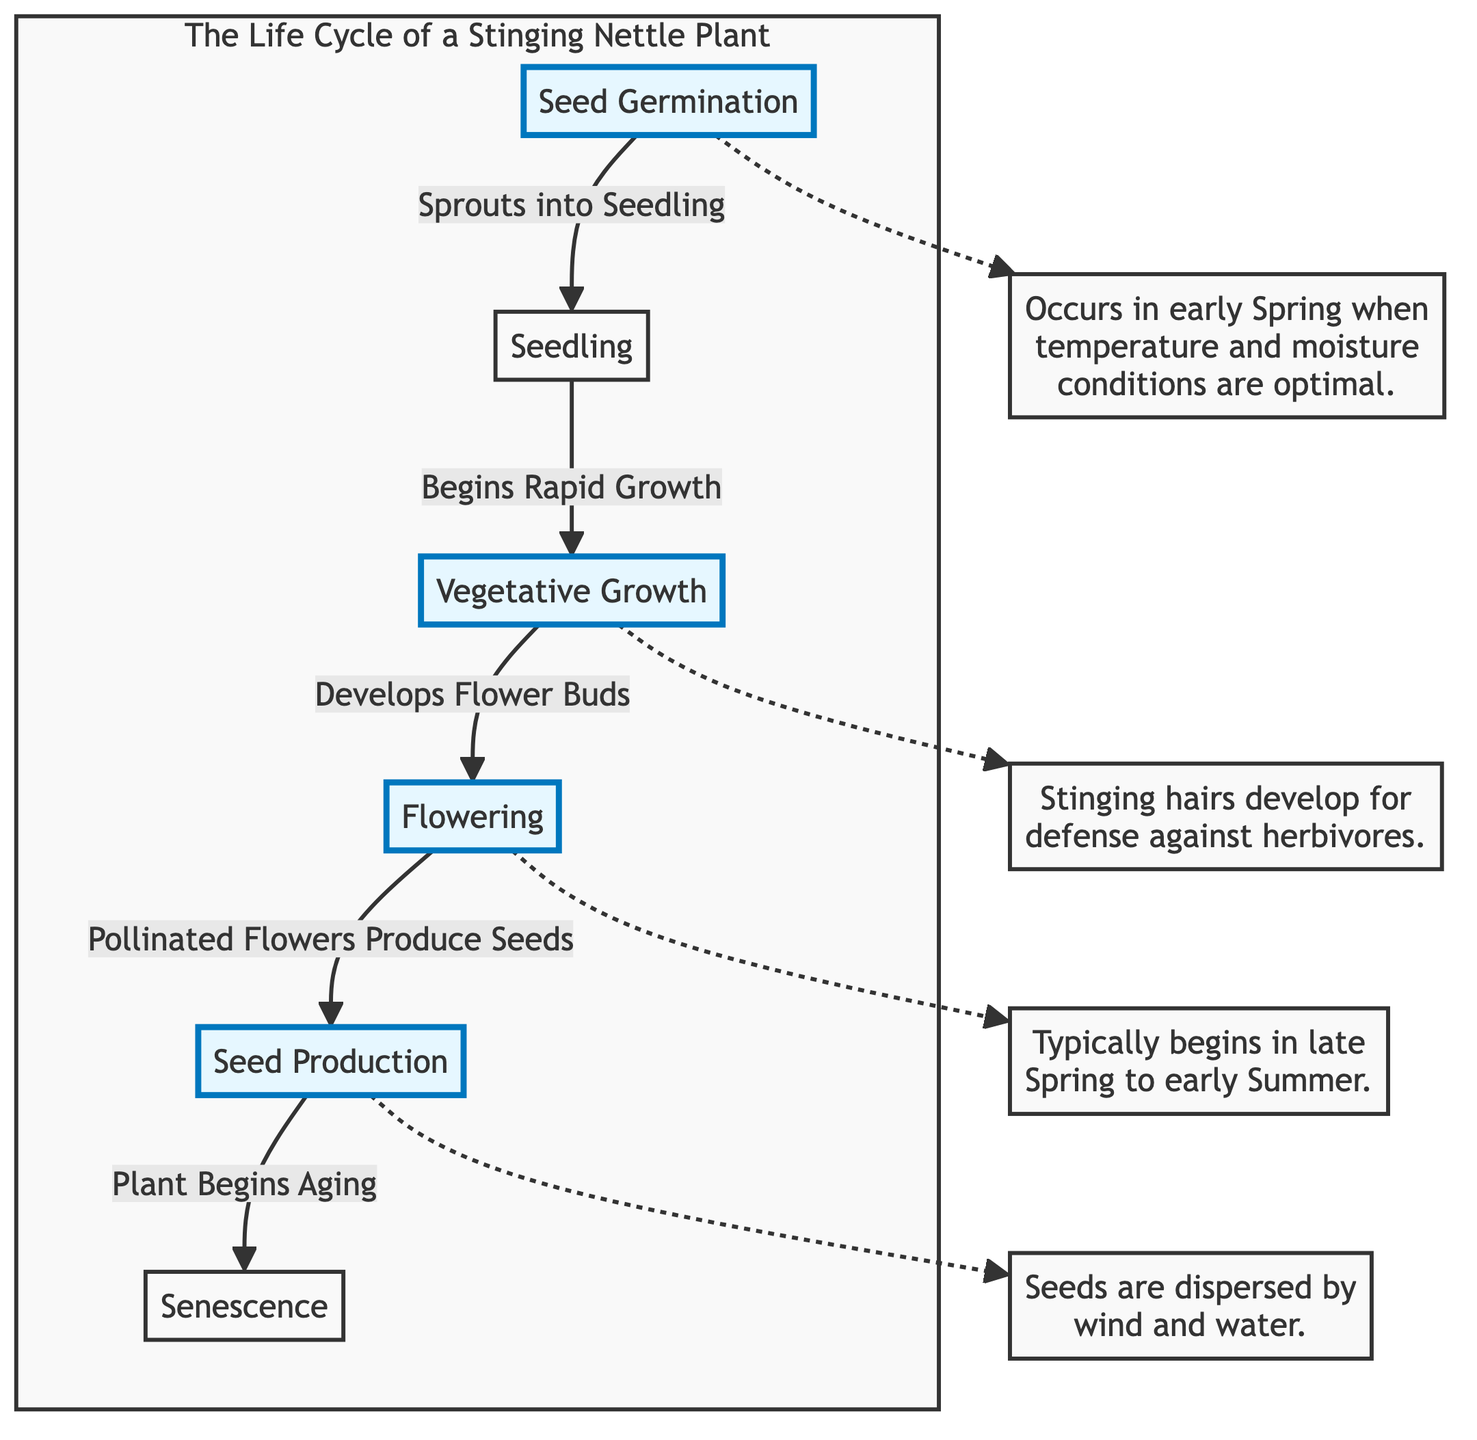What is the first stage of the life cycle? The diagram begins with "Seed Germination" as the first stage.
Answer: Seed Germination How many stages are highlighted in the diagram? The diagram highlights the stages of Seed Germination, Vegetative Growth, Flowering, and Seed Production, totaling four highlighted stages.
Answer: 4 What follows after the Seedling stage? The diagram indicates that "Seedling" transitions into "Vegetative Growth."
Answer: Vegetative Growth At which stage do flowers bud? According to the diagram, "Vegetative Growth" develops into "Flowering," which is when flower buds are formed.
Answer: Flowering What does the plant produce after flowering? The diagram shows that after the "Flowering" stage, the next step is "Seed Production."
Answer: Seed Production Which stage involves the development of stinging hairs? The notes connected to "Vegetative Growth" explain that stinging hairs develop for defense against herbivores during this stage.
Answer: Vegetative Growth How does the plant age? The diagram notes that the aging process begins at "Seed Production," indicating how the plant starts to senesce afterward.
Answer: Seed Production What environmental conditions favor seed germination? The note linked to "Seed Germination" states that this occurs in early Spring when temperature and moisture conditions are optimal.
Answer: Early Spring Which process is responsible for seed dispersal? The note tied to "Seed Production" indicates that seeds are dispersed by wind and water.
Answer: Wind and water 